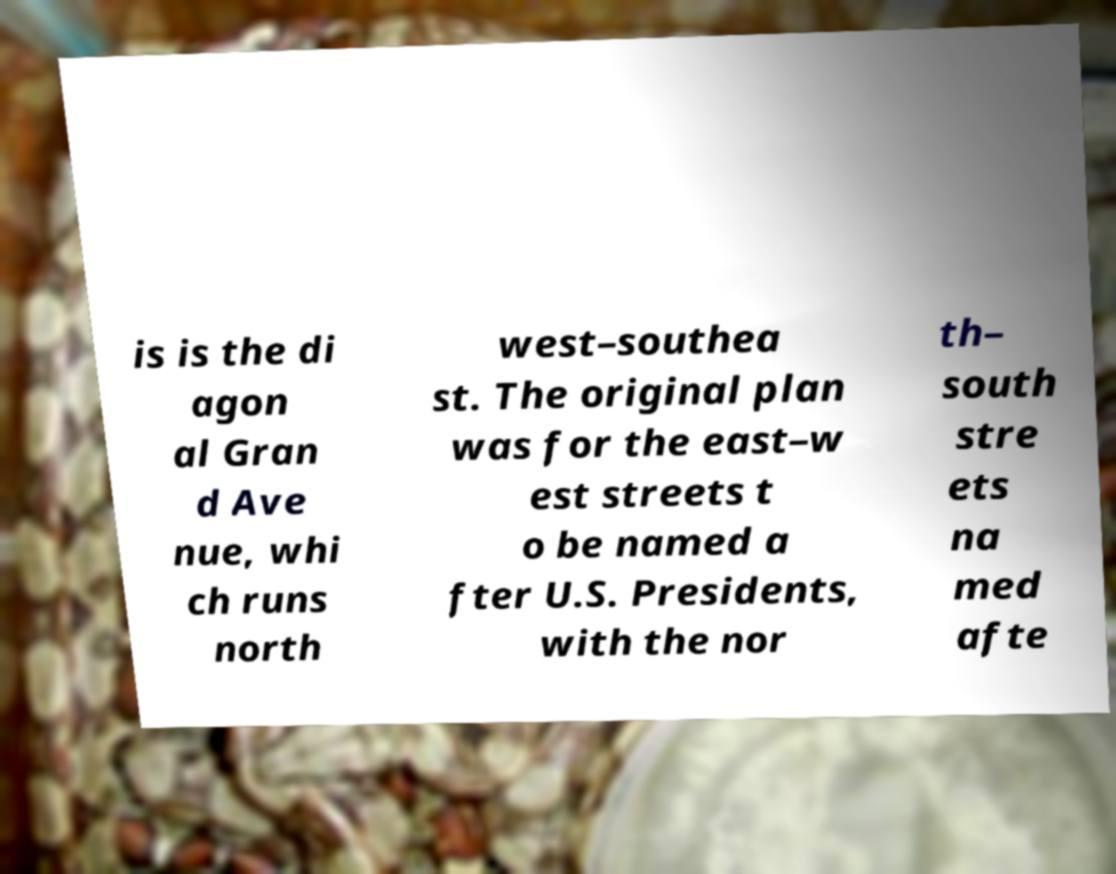Could you extract and type out the text from this image? is is the di agon al Gran d Ave nue, whi ch runs north west–southea st. The original plan was for the east–w est streets t o be named a fter U.S. Presidents, with the nor th– south stre ets na med afte 